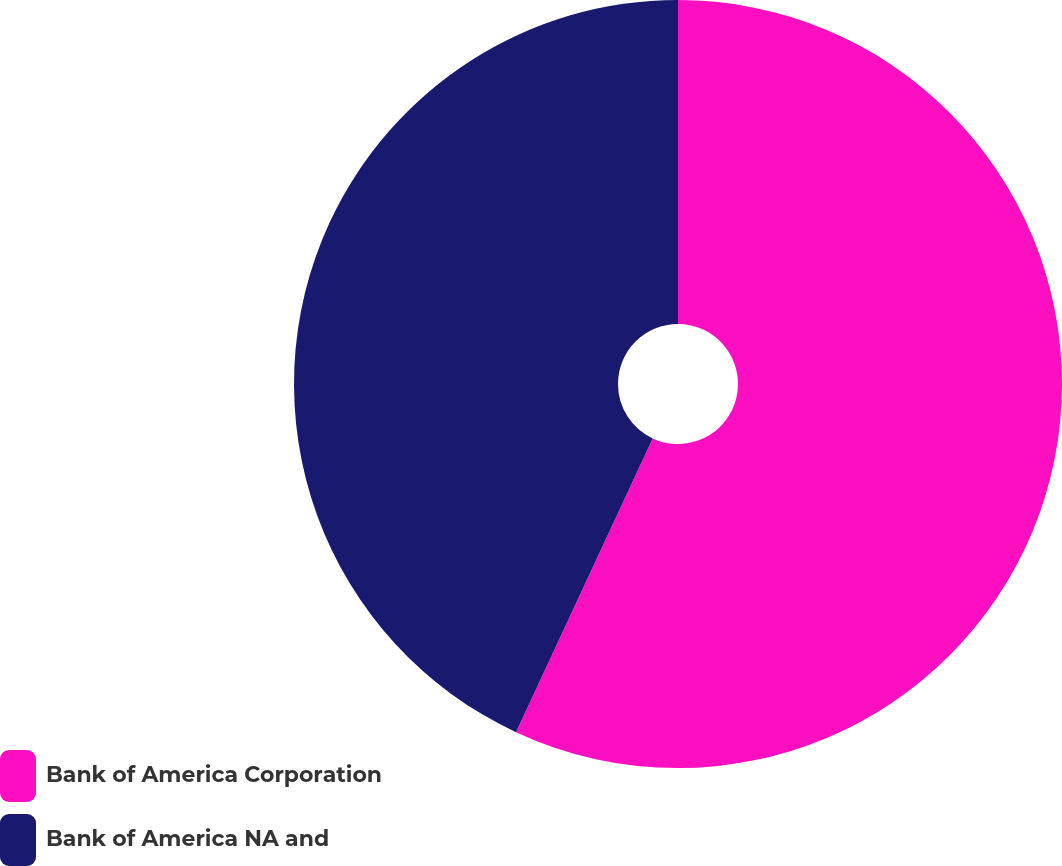Convert chart to OTSL. <chart><loc_0><loc_0><loc_500><loc_500><pie_chart><fcel>Bank of America Corporation<fcel>Bank of America NA and<nl><fcel>56.93%<fcel>43.07%<nl></chart> 